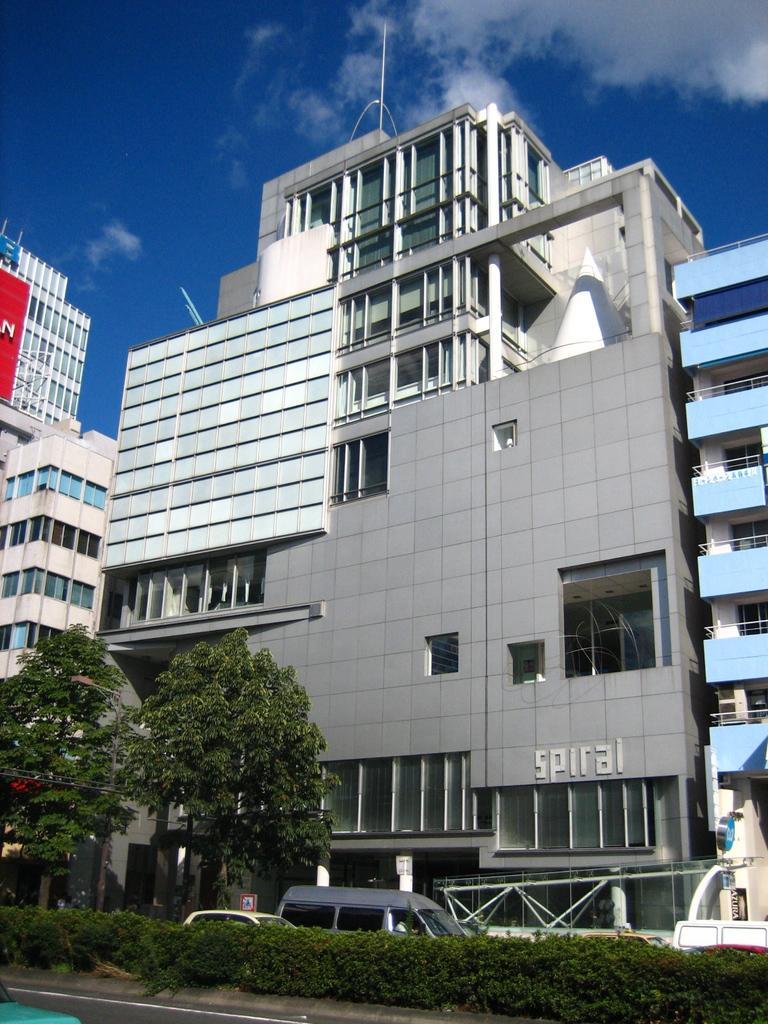Could you give a brief overview of what you see in this image? This picture is clicked outside. In the foreground we can see the plants, trees and the vehicles and we can see the metal rods. In the center we can see the buildings and the text on the wall of the building. In the background we can see the sky with some clouds and we can see some other items. 